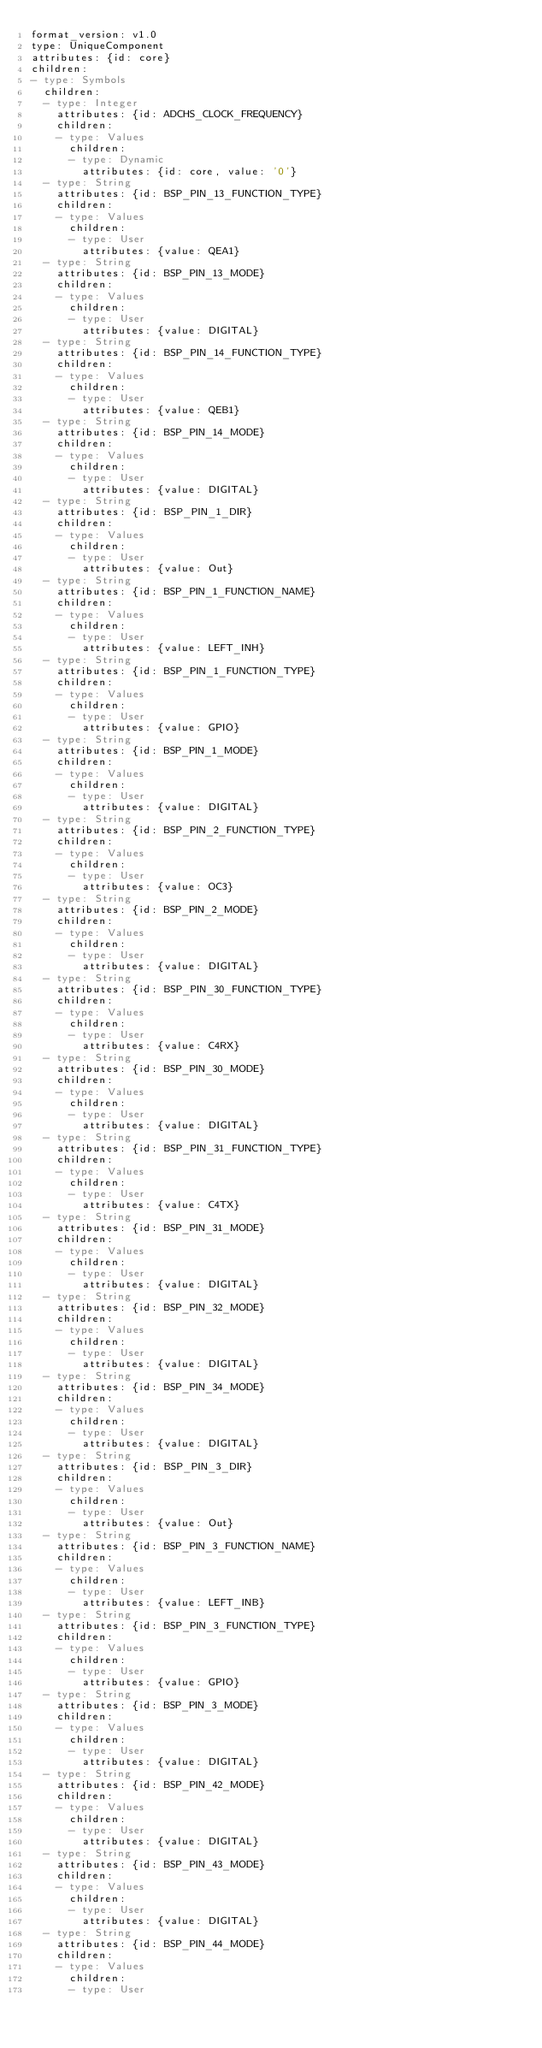Convert code to text. <code><loc_0><loc_0><loc_500><loc_500><_YAML_>format_version: v1.0
type: UniqueComponent
attributes: {id: core}
children:
- type: Symbols
  children:
  - type: Integer
    attributes: {id: ADCHS_CLOCK_FREQUENCY}
    children:
    - type: Values
      children:
      - type: Dynamic
        attributes: {id: core, value: '0'}
  - type: String
    attributes: {id: BSP_PIN_13_FUNCTION_TYPE}
    children:
    - type: Values
      children:
      - type: User
        attributes: {value: QEA1}
  - type: String
    attributes: {id: BSP_PIN_13_MODE}
    children:
    - type: Values
      children:
      - type: User
        attributes: {value: DIGITAL}
  - type: String
    attributes: {id: BSP_PIN_14_FUNCTION_TYPE}
    children:
    - type: Values
      children:
      - type: User
        attributes: {value: QEB1}
  - type: String
    attributes: {id: BSP_PIN_14_MODE}
    children:
    - type: Values
      children:
      - type: User
        attributes: {value: DIGITAL}
  - type: String
    attributes: {id: BSP_PIN_1_DIR}
    children:
    - type: Values
      children:
      - type: User
        attributes: {value: Out}
  - type: String
    attributes: {id: BSP_PIN_1_FUNCTION_NAME}
    children:
    - type: Values
      children:
      - type: User
        attributes: {value: LEFT_INH}
  - type: String
    attributes: {id: BSP_PIN_1_FUNCTION_TYPE}
    children:
    - type: Values
      children:
      - type: User
        attributes: {value: GPIO}
  - type: String
    attributes: {id: BSP_PIN_1_MODE}
    children:
    - type: Values
      children:
      - type: User
        attributes: {value: DIGITAL}
  - type: String
    attributes: {id: BSP_PIN_2_FUNCTION_TYPE}
    children:
    - type: Values
      children:
      - type: User
        attributes: {value: OC3}
  - type: String
    attributes: {id: BSP_PIN_2_MODE}
    children:
    - type: Values
      children:
      - type: User
        attributes: {value: DIGITAL}
  - type: String
    attributes: {id: BSP_PIN_30_FUNCTION_TYPE}
    children:
    - type: Values
      children:
      - type: User
        attributes: {value: C4RX}
  - type: String
    attributes: {id: BSP_PIN_30_MODE}
    children:
    - type: Values
      children:
      - type: User
        attributes: {value: DIGITAL}
  - type: String
    attributes: {id: BSP_PIN_31_FUNCTION_TYPE}
    children:
    - type: Values
      children:
      - type: User
        attributes: {value: C4TX}
  - type: String
    attributes: {id: BSP_PIN_31_MODE}
    children:
    - type: Values
      children:
      - type: User
        attributes: {value: DIGITAL}
  - type: String
    attributes: {id: BSP_PIN_32_MODE}
    children:
    - type: Values
      children:
      - type: User
        attributes: {value: DIGITAL}
  - type: String
    attributes: {id: BSP_PIN_34_MODE}
    children:
    - type: Values
      children:
      - type: User
        attributes: {value: DIGITAL}
  - type: String
    attributes: {id: BSP_PIN_3_DIR}
    children:
    - type: Values
      children:
      - type: User
        attributes: {value: Out}
  - type: String
    attributes: {id: BSP_PIN_3_FUNCTION_NAME}
    children:
    - type: Values
      children:
      - type: User
        attributes: {value: LEFT_INB}
  - type: String
    attributes: {id: BSP_PIN_3_FUNCTION_TYPE}
    children:
    - type: Values
      children:
      - type: User
        attributes: {value: GPIO}
  - type: String
    attributes: {id: BSP_PIN_3_MODE}
    children:
    - type: Values
      children:
      - type: User
        attributes: {value: DIGITAL}
  - type: String
    attributes: {id: BSP_PIN_42_MODE}
    children:
    - type: Values
      children:
      - type: User
        attributes: {value: DIGITAL}
  - type: String
    attributes: {id: BSP_PIN_43_MODE}
    children:
    - type: Values
      children:
      - type: User
        attributes: {value: DIGITAL}
  - type: String
    attributes: {id: BSP_PIN_44_MODE}
    children:
    - type: Values
      children:
      - type: User</code> 